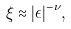<formula> <loc_0><loc_0><loc_500><loc_500>\xi \approx | \epsilon | ^ { - \nu } ,</formula> 